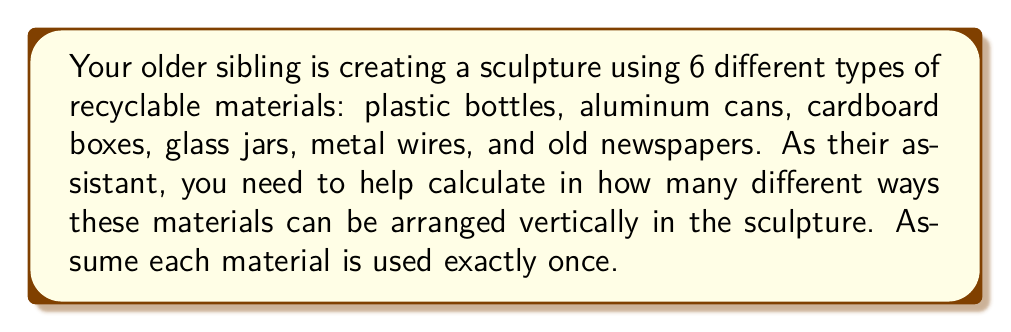Show me your answer to this math problem. To solve this problem, we need to use the concept of permutations. Since we are arranging all 6 materials, and each material is used exactly once, this is a straightforward permutation problem.

The formula for permutations of $n$ distinct objects is:

$$P(n) = n!$$

Where $n!$ represents the factorial of $n$.

In this case, we have 6 different types of recyclable materials, so $n = 6$.

Let's calculate step by step:

1) $P(6) = 6!$
2) $6! = 6 \times 5 \times 4 \times 3 \times 2 \times 1$
3) $6! = 720$

Therefore, there are 720 different ways to arrange the 6 recyclable materials vertically in the sculpture.

This means that your sibling has 720 different options to create unique vertical arrangements of these materials in their sculpture.
Answer: $720$ ways 